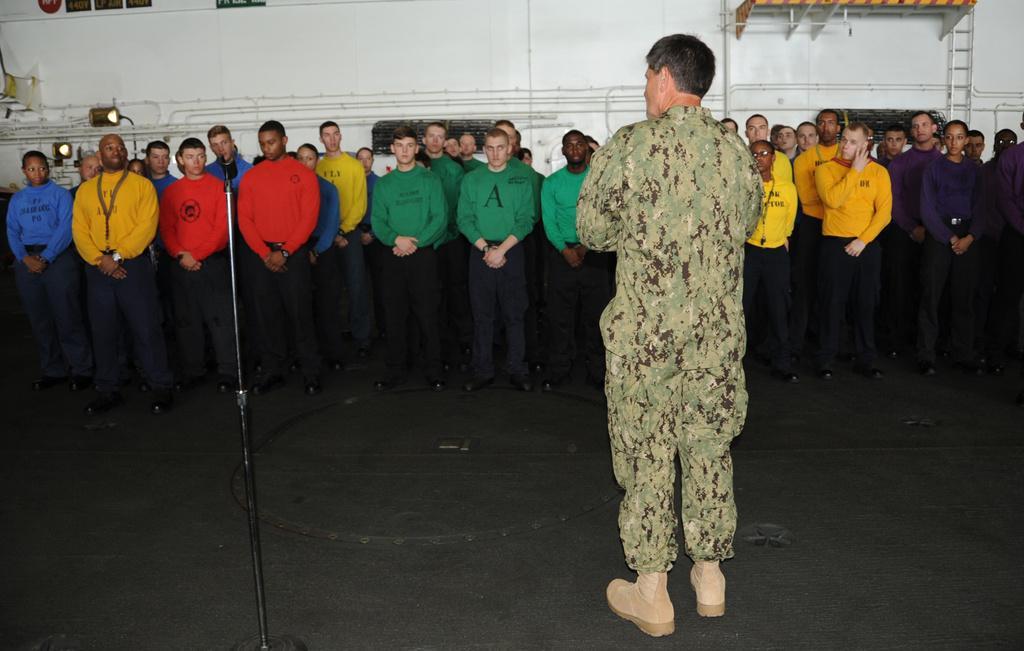Could you give a brief overview of what you see in this image? In this picture we can see a group of people standing and a stand on the floor and in the background we can see wall. 